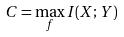Convert formula to latex. <formula><loc_0><loc_0><loc_500><loc_500>C = \max _ { f } I ( X ; Y )</formula> 